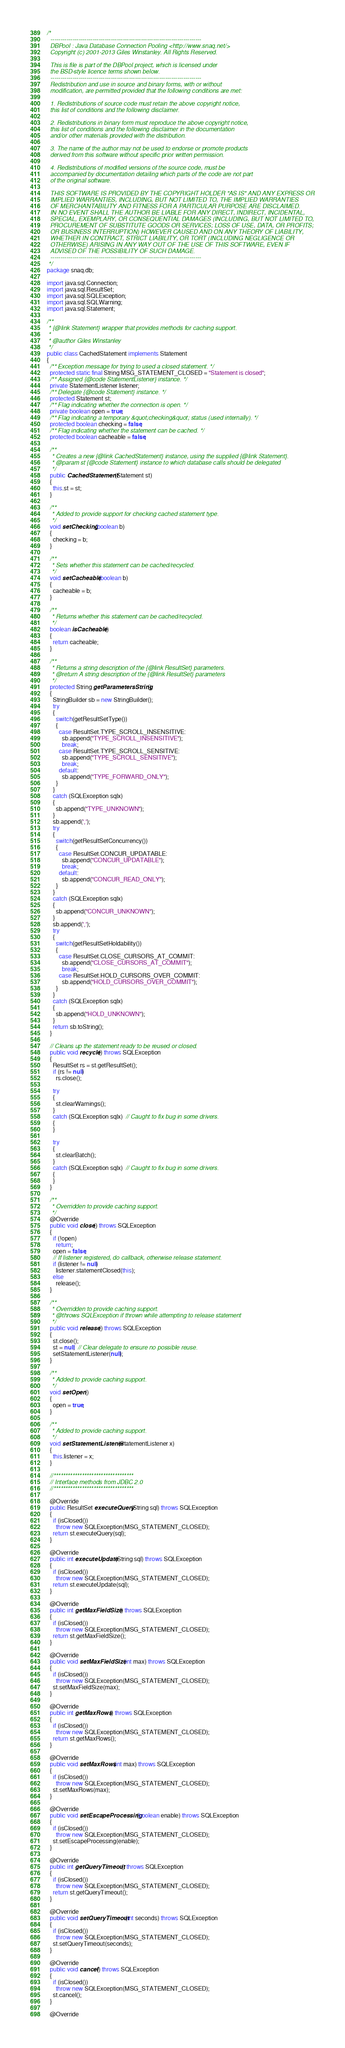Convert code to text. <code><loc_0><loc_0><loc_500><loc_500><_Java_>/*
  ---------------------------------------------------------------------------
  DBPool : Java Database Connection Pooling <http://www.snaq.net/>
  Copyright (c) 2001-2013 Giles Winstanley. All Rights Reserved.

  This is file is part of the DBPool project, which is licensed under
  the BSD-style licence terms shown below.
  ---------------------------------------------------------------------------
  Redistribution and use in source and binary forms, with or without
  modification, are permitted provided that the following conditions are met:

  1. Redistributions of source code must retain the above copyright notice,
  this list of conditions and the following disclaimer.

  2. Redistributions in binary form must reproduce the above copyright notice,
  this list of conditions and the following disclaimer in the documentation
  and/or other materials provided with the distribution.

  3. The name of the author may not be used to endorse or promote products
  derived from this software without specific prior written permission.

  4. Redistributions of modified versions of the source code, must be
  accompanied by documentation detailing which parts of the code are not part
  of the original software.

  THIS SOFTWARE IS PROVIDED BY THE COPYRIGHT HOLDER "AS IS" AND ANY EXPRESS OR
  IMPLIED WARRANTIES, INCLUDING, BUT NOT LIMITED TO, THE IMPLIED WARRANTIES
  OF MERCHANTABILITY AND FITNESS FOR A PARTICULAR PURPOSE ARE DISCLAIMED.
  IN NO EVENT SHALL THE AUTHOR BE LIABLE FOR ANY DIRECT, INDIRECT, INCIDENTAL,
  SPECIAL, EXEMPLARY, OR CONSEQUENTIAL DAMAGES (INCLUDING, BUT NOT LIMITED TO,
  PROCUREMENT OF SUBSTITUTE GOODS OR SERVICES; LOSS OF USE, DATA, OR PROFITS;
  OR BUSINESS INTERRUPTION) HOWEVER CAUSED AND ON ANY THEORY OF LIABILITY,
  WHETHER IN CONTRACT, STRICT LIABILITY, OR TORT (INCLUDING NEGLIGENCE OR
  OTHERWISE) ARISING IN ANY WAY OUT OF THE USE OF THIS SOFTWARE, EVEN IF
  ADVISED OF THE POSSIBILITY OF SUCH DAMAGE.
  ---------------------------------------------------------------------------
 */
package snaq.db;

import java.sql.Connection;
import java.sql.ResultSet;
import java.sql.SQLException;
import java.sql.SQLWarning;
import java.sql.Statement;

/**
 * {@link Statement} wrapper that provides methods for caching support.
 *
 * @author Giles Winstanley
 */
public class CachedStatement implements Statement
{
  /** Exception message for trying to used a closed statement. */
  protected static final String MSG_STATEMENT_CLOSED = "Statement is closed";
  /** Assigned {@code StatementListener} instance. */
  private StatementListener listener;
  /** Delegate {@code Statement} instance. */
  protected Statement st;
  /** Flag indicating whether the connection is open. */
  private boolean open = true;
  /** Flag indicating a temporary &quot;checking&quot; status (used internally). */
  protected boolean checking = false;
  /** Flag indicating whether the statement can be cached. */
  protected boolean cacheable = false;

  /**
   * Creates a new {@link CachedStatement} instance, using the supplied {@link Statement}.
   * @param st {@code Statement} instance to which database calls should be delegated
   */
  public CachedStatement(Statement st)
  {
    this.st = st;
  }

  /**
   * Added to provide support for checking cached statement type.
   */
  void setChecking(boolean b)
  {
    checking = b;
  }

  /**
   * Sets whether this statement can be cached/recycled.
   */
  void setCacheable(boolean b)
  {
    cacheable = b;
  }

  /**
   * Returns whether this statement can be cached/recycled.
   */
  boolean isCacheable()
  {
    return cacheable;
  }

  /**
   * Returns a string description of the {@link ResultSet} parameters.
   * @return A string description of the {@link ResultSet} parameters
   */
  protected String getParametersString()
  {
    StringBuilder sb = new StringBuilder();
    try
    {
      switch(getResultSetType())
      {
        case ResultSet.TYPE_SCROLL_INSENSITIVE:
          sb.append("TYPE_SCROLL_INSENSITIVE");
          break;
        case ResultSet.TYPE_SCROLL_SENSITIVE:
          sb.append("TYPE_SCROLL_SENSITIVE");
          break;
        default:
          sb.append("TYPE_FORWARD_ONLY");
      }
    }
    catch (SQLException sqlx)
    {
      sb.append("TYPE_UNKNOWN");
    }
    sb.append(',');
    try
    {
      switch(getResultSetConcurrency())
      {
        case ResultSet.CONCUR_UPDATABLE:
          sb.append("CONCUR_UPDATABLE");
          break;
        default:
          sb.append("CONCUR_READ_ONLY");
      }
    }
    catch (SQLException sqlx)
    {
      sb.append("CONCUR_UNKNOWN");
    }
    sb.append(',');
    try
    {
      switch(getResultSetHoldability())
      {
        case ResultSet.CLOSE_CURSORS_AT_COMMIT:
          sb.append("CLOSE_CURSORS_AT_COMMIT");
          break;
        case ResultSet.HOLD_CURSORS_OVER_COMMIT:
          sb.append("HOLD_CURSORS_OVER_COMMIT");
      }
    }
    catch (SQLException sqlx)
    {
      sb.append("HOLD_UNKNOWN");
    }
    return sb.toString();
  }

  // Cleans up the statement ready to be reused or closed.
  public void recycle() throws SQLException
  {
    ResultSet rs = st.getResultSet();
    if (rs != null)
      rs.close();

    try
    {
      st.clearWarnings();
    }
    catch (SQLException sqlx)  // Caught to fix bug in some drivers.
    {
    }

    try
    {
      st.clearBatch();
    }
    catch (SQLException sqlx)  // Caught to fix bug in some drivers.
    {
    }
  }

  /**
   * Overridden to provide caching support.
   */
  @Override
  public void close() throws SQLException
  {
    if (!open)
      return;
    open = false;
    // If listener registered, do callback, otherwise release statement.
    if (listener != null)
      listener.statementClosed(this);
    else
      release();
  }

  /**
   * Overridden to provide caching support.
   * @throws SQLException if thrown while attempting to release statement
   */
  public void release() throws SQLException
  {
    st.close();
    st = null;  // Clear delegate to ensure no possible reuse.
    setStatementListener(null);
  }

  /**
   * Added to provide caching support.
   */
  void setOpen()
  {
    open = true;
  }

  /**
   * Added to provide caching support.
   */
  void setStatementListener(StatementListener x)
  {
    this.listener = x;
  }

  //**********************************
  // Interface methods from JDBC 2.0
  //**********************************

  @Override
  public ResultSet executeQuery(String sql) throws SQLException
  {
    if (isClosed())
      throw new SQLException(MSG_STATEMENT_CLOSED);
    return st.executeQuery(sql);
  }

  @Override
  public int executeUpdate(String sql) throws SQLException
  {
    if (isClosed())
      throw new SQLException(MSG_STATEMENT_CLOSED);
    return st.executeUpdate(sql);
  }

  @Override
  public int getMaxFieldSize() throws SQLException
  {
    if (isClosed())
      throw new SQLException(MSG_STATEMENT_CLOSED);
    return st.getMaxFieldSize();
  }

  @Override
  public void setMaxFieldSize(int max) throws SQLException
  {
    if (isClosed())
      throw new SQLException(MSG_STATEMENT_CLOSED);
    st.setMaxFieldSize(max);
  }

  @Override
  public int getMaxRows() throws SQLException
  {
    if (isClosed())
      throw new SQLException(MSG_STATEMENT_CLOSED);
    return st.getMaxRows();
  }

  @Override
  public void setMaxRows(int max) throws SQLException
  {
    if (isClosed())
      throw new SQLException(MSG_STATEMENT_CLOSED);
    st.setMaxRows(max);
  }

  @Override
  public void setEscapeProcessing(boolean enable) throws SQLException
  {
    if (isClosed())
      throw new SQLException(MSG_STATEMENT_CLOSED);
    st.setEscapeProcessing(enable);
  }

  @Override
  public int getQueryTimeout() throws SQLException
  {
    if (isClosed())
      throw new SQLException(MSG_STATEMENT_CLOSED);
    return st.getQueryTimeout();
  }

  @Override
  public void setQueryTimeout(int seconds) throws SQLException
  {
    if (isClosed())
      throw new SQLException(MSG_STATEMENT_CLOSED);
    st.setQueryTimeout(seconds);
  }

  @Override
  public void cancel() throws SQLException
  {
    if (isClosed())
      throw new SQLException(MSG_STATEMENT_CLOSED);
    st.cancel();
  }

  @Override</code> 